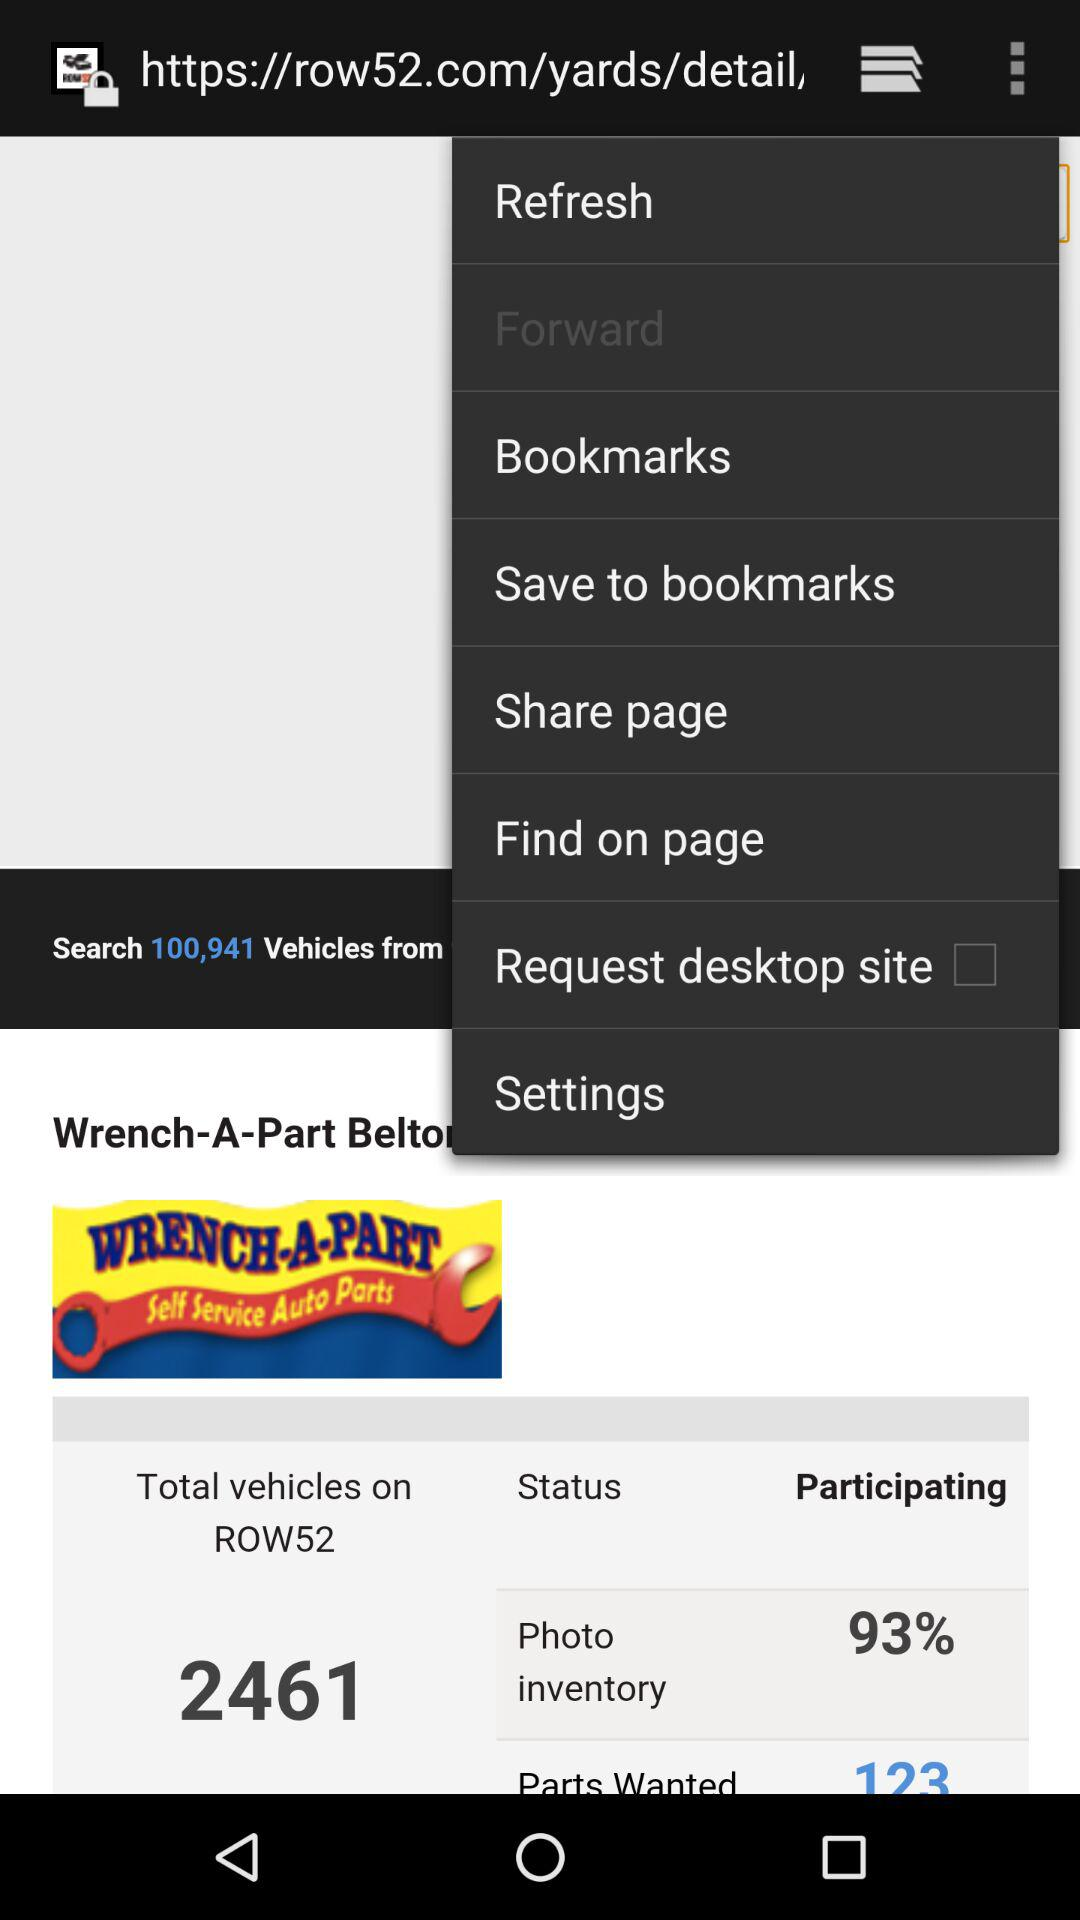Which option is selected?
When the provided information is insufficient, respond with <no answer>. <no answer> 